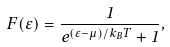Convert formula to latex. <formula><loc_0><loc_0><loc_500><loc_500>F ( \varepsilon ) = { \frac { 1 } { e ^ { ( \varepsilon - \mu ) / k _ { B } T } + 1 } } ,</formula> 